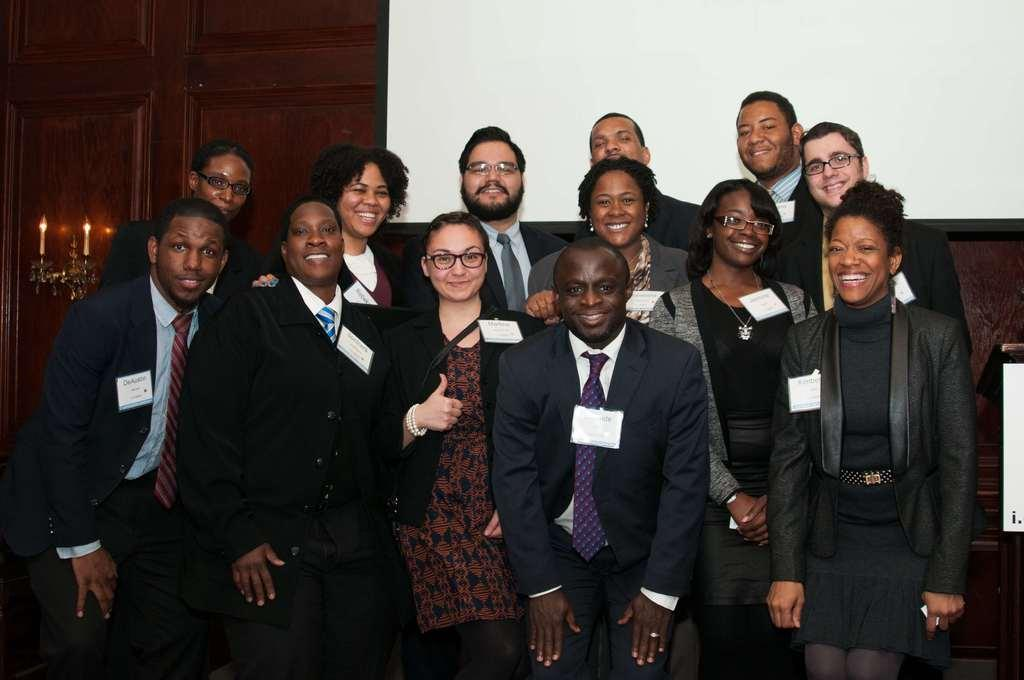What is happening in the image involving a group of people? The people in the image are posing for a camera. How are the people in the image expressing themselves? The people in the image are smiling. What can be seen in the background of the image? There is a wall, a door, and lights in the background of the image. Can you tell me which person's ear is closest to the camera in the image? There is no specific ear mentioned in the image, as it focuses on the group of people posing for a camera. 